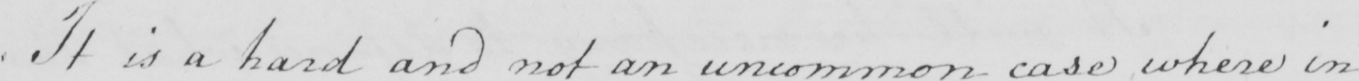What is written in this line of handwriting? It is a hard and not an uncommon case where in 